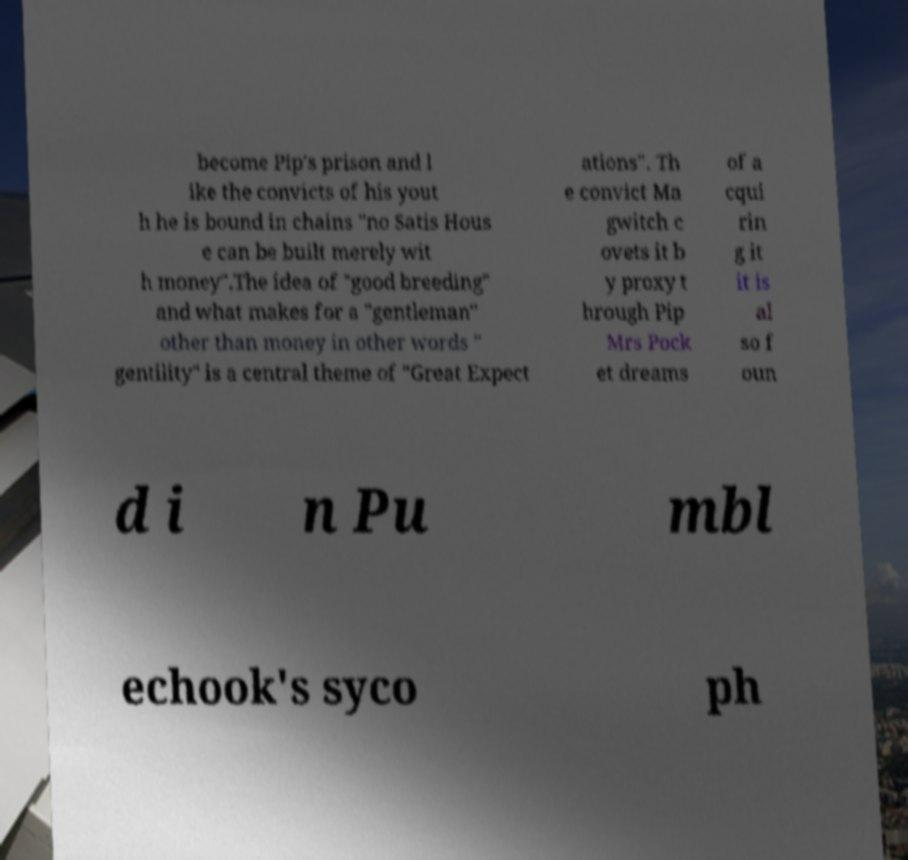Can you accurately transcribe the text from the provided image for me? become Pip's prison and l ike the convicts of his yout h he is bound in chains "no Satis Hous e can be built merely wit h money".The idea of "good breeding" and what makes for a "gentleman" other than money in other words " gentility" is a central theme of "Great Expect ations". Th e convict Ma gwitch c ovets it b y proxy t hrough Pip Mrs Pock et dreams of a cqui rin g it it is al so f oun d i n Pu mbl echook's syco ph 